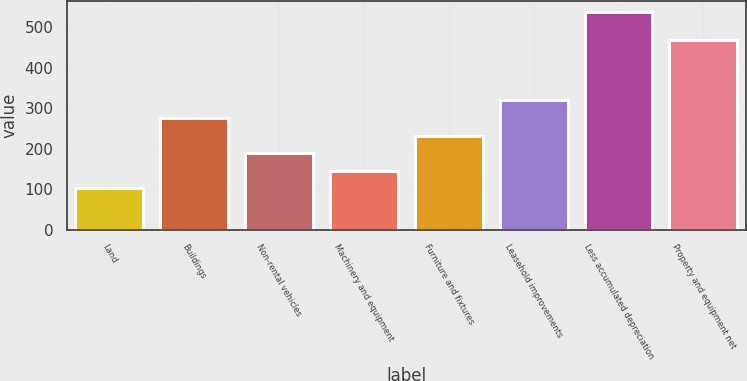Convert chart. <chart><loc_0><loc_0><loc_500><loc_500><bar_chart><fcel>Land<fcel>Buildings<fcel>Non-rental vehicles<fcel>Machinery and equipment<fcel>Furniture and fixtures<fcel>Leasehold improvements<fcel>Less accumulated depreciation<fcel>Property and equipment net<nl><fcel>102<fcel>276<fcel>189<fcel>145.5<fcel>232.5<fcel>319.5<fcel>537<fcel>467<nl></chart> 